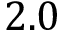<formula> <loc_0><loc_0><loc_500><loc_500>2 . 0</formula> 